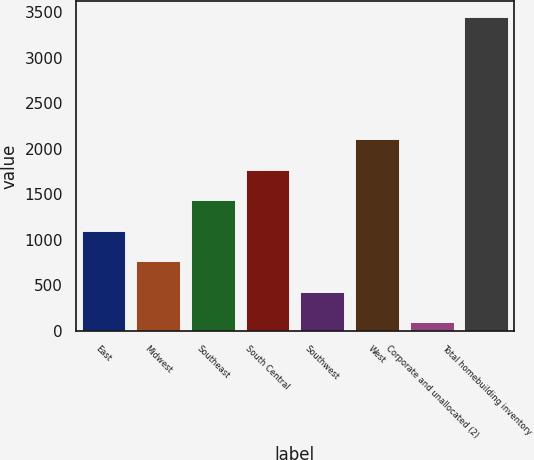Convert chart to OTSL. <chart><loc_0><loc_0><loc_500><loc_500><bar_chart><fcel>East<fcel>Midwest<fcel>Southeast<fcel>South Central<fcel>Southwest<fcel>West<fcel>Corporate and unallocated (2)<fcel>Total homebuilding inventory<nl><fcel>1098.26<fcel>762.34<fcel>1434.18<fcel>1770.1<fcel>426.42<fcel>2106.02<fcel>90.5<fcel>3449.7<nl></chart> 